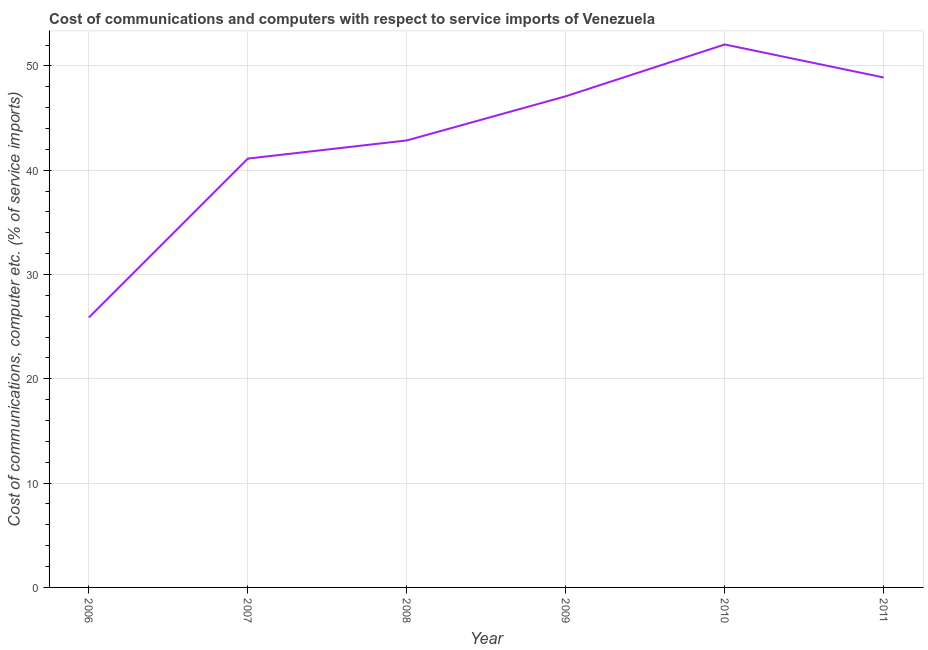What is the cost of communications and computer in 2008?
Your answer should be compact. 42.85. Across all years, what is the maximum cost of communications and computer?
Your response must be concise. 52.05. Across all years, what is the minimum cost of communications and computer?
Your response must be concise. 25.88. What is the sum of the cost of communications and computer?
Your response must be concise. 257.87. What is the difference between the cost of communications and computer in 2006 and 2011?
Offer a very short reply. -23.01. What is the average cost of communications and computer per year?
Provide a short and direct response. 42.98. What is the median cost of communications and computer?
Your answer should be very brief. 44.97. Do a majority of the years between 2007 and 2008 (inclusive) have cost of communications and computer greater than 32 %?
Provide a succinct answer. Yes. What is the ratio of the cost of communications and computer in 2008 to that in 2010?
Ensure brevity in your answer.  0.82. Is the cost of communications and computer in 2008 less than that in 2010?
Offer a terse response. Yes. What is the difference between the highest and the second highest cost of communications and computer?
Ensure brevity in your answer.  3.16. What is the difference between the highest and the lowest cost of communications and computer?
Ensure brevity in your answer.  26.18. In how many years, is the cost of communications and computer greater than the average cost of communications and computer taken over all years?
Ensure brevity in your answer.  3. Does the cost of communications and computer monotonically increase over the years?
Ensure brevity in your answer.  No. How many lines are there?
Your response must be concise. 1. What is the difference between two consecutive major ticks on the Y-axis?
Your answer should be compact. 10. Are the values on the major ticks of Y-axis written in scientific E-notation?
Keep it short and to the point. No. Does the graph contain any zero values?
Make the answer very short. No. Does the graph contain grids?
Provide a short and direct response. Yes. What is the title of the graph?
Make the answer very short. Cost of communications and computers with respect to service imports of Venezuela. What is the label or title of the Y-axis?
Give a very brief answer. Cost of communications, computer etc. (% of service imports). What is the Cost of communications, computer etc. (% of service imports) of 2006?
Offer a very short reply. 25.88. What is the Cost of communications, computer etc. (% of service imports) of 2007?
Offer a terse response. 41.11. What is the Cost of communications, computer etc. (% of service imports) in 2008?
Ensure brevity in your answer.  42.85. What is the Cost of communications, computer etc. (% of service imports) in 2009?
Ensure brevity in your answer.  47.09. What is the Cost of communications, computer etc. (% of service imports) in 2010?
Give a very brief answer. 52.05. What is the Cost of communications, computer etc. (% of service imports) of 2011?
Your answer should be compact. 48.89. What is the difference between the Cost of communications, computer etc. (% of service imports) in 2006 and 2007?
Your answer should be very brief. -15.24. What is the difference between the Cost of communications, computer etc. (% of service imports) in 2006 and 2008?
Offer a very short reply. -16.98. What is the difference between the Cost of communications, computer etc. (% of service imports) in 2006 and 2009?
Your response must be concise. -21.21. What is the difference between the Cost of communications, computer etc. (% of service imports) in 2006 and 2010?
Provide a short and direct response. -26.18. What is the difference between the Cost of communications, computer etc. (% of service imports) in 2006 and 2011?
Provide a succinct answer. -23.01. What is the difference between the Cost of communications, computer etc. (% of service imports) in 2007 and 2008?
Keep it short and to the point. -1.74. What is the difference between the Cost of communications, computer etc. (% of service imports) in 2007 and 2009?
Keep it short and to the point. -5.97. What is the difference between the Cost of communications, computer etc. (% of service imports) in 2007 and 2010?
Your response must be concise. -10.94. What is the difference between the Cost of communications, computer etc. (% of service imports) in 2007 and 2011?
Provide a short and direct response. -7.77. What is the difference between the Cost of communications, computer etc. (% of service imports) in 2008 and 2009?
Your response must be concise. -4.23. What is the difference between the Cost of communications, computer etc. (% of service imports) in 2008 and 2010?
Provide a short and direct response. -9.2. What is the difference between the Cost of communications, computer etc. (% of service imports) in 2008 and 2011?
Offer a terse response. -6.03. What is the difference between the Cost of communications, computer etc. (% of service imports) in 2009 and 2010?
Offer a terse response. -4.96. What is the difference between the Cost of communications, computer etc. (% of service imports) in 2009 and 2011?
Give a very brief answer. -1.8. What is the difference between the Cost of communications, computer etc. (% of service imports) in 2010 and 2011?
Your response must be concise. 3.16. What is the ratio of the Cost of communications, computer etc. (% of service imports) in 2006 to that in 2007?
Your answer should be compact. 0.63. What is the ratio of the Cost of communications, computer etc. (% of service imports) in 2006 to that in 2008?
Provide a short and direct response. 0.6. What is the ratio of the Cost of communications, computer etc. (% of service imports) in 2006 to that in 2009?
Offer a very short reply. 0.55. What is the ratio of the Cost of communications, computer etc. (% of service imports) in 2006 to that in 2010?
Give a very brief answer. 0.5. What is the ratio of the Cost of communications, computer etc. (% of service imports) in 2006 to that in 2011?
Provide a succinct answer. 0.53. What is the ratio of the Cost of communications, computer etc. (% of service imports) in 2007 to that in 2009?
Provide a succinct answer. 0.87. What is the ratio of the Cost of communications, computer etc. (% of service imports) in 2007 to that in 2010?
Offer a very short reply. 0.79. What is the ratio of the Cost of communications, computer etc. (% of service imports) in 2007 to that in 2011?
Your answer should be very brief. 0.84. What is the ratio of the Cost of communications, computer etc. (% of service imports) in 2008 to that in 2009?
Your answer should be very brief. 0.91. What is the ratio of the Cost of communications, computer etc. (% of service imports) in 2008 to that in 2010?
Offer a very short reply. 0.82. What is the ratio of the Cost of communications, computer etc. (% of service imports) in 2008 to that in 2011?
Offer a very short reply. 0.88. What is the ratio of the Cost of communications, computer etc. (% of service imports) in 2009 to that in 2010?
Your response must be concise. 0.91. What is the ratio of the Cost of communications, computer etc. (% of service imports) in 2010 to that in 2011?
Keep it short and to the point. 1.06. 